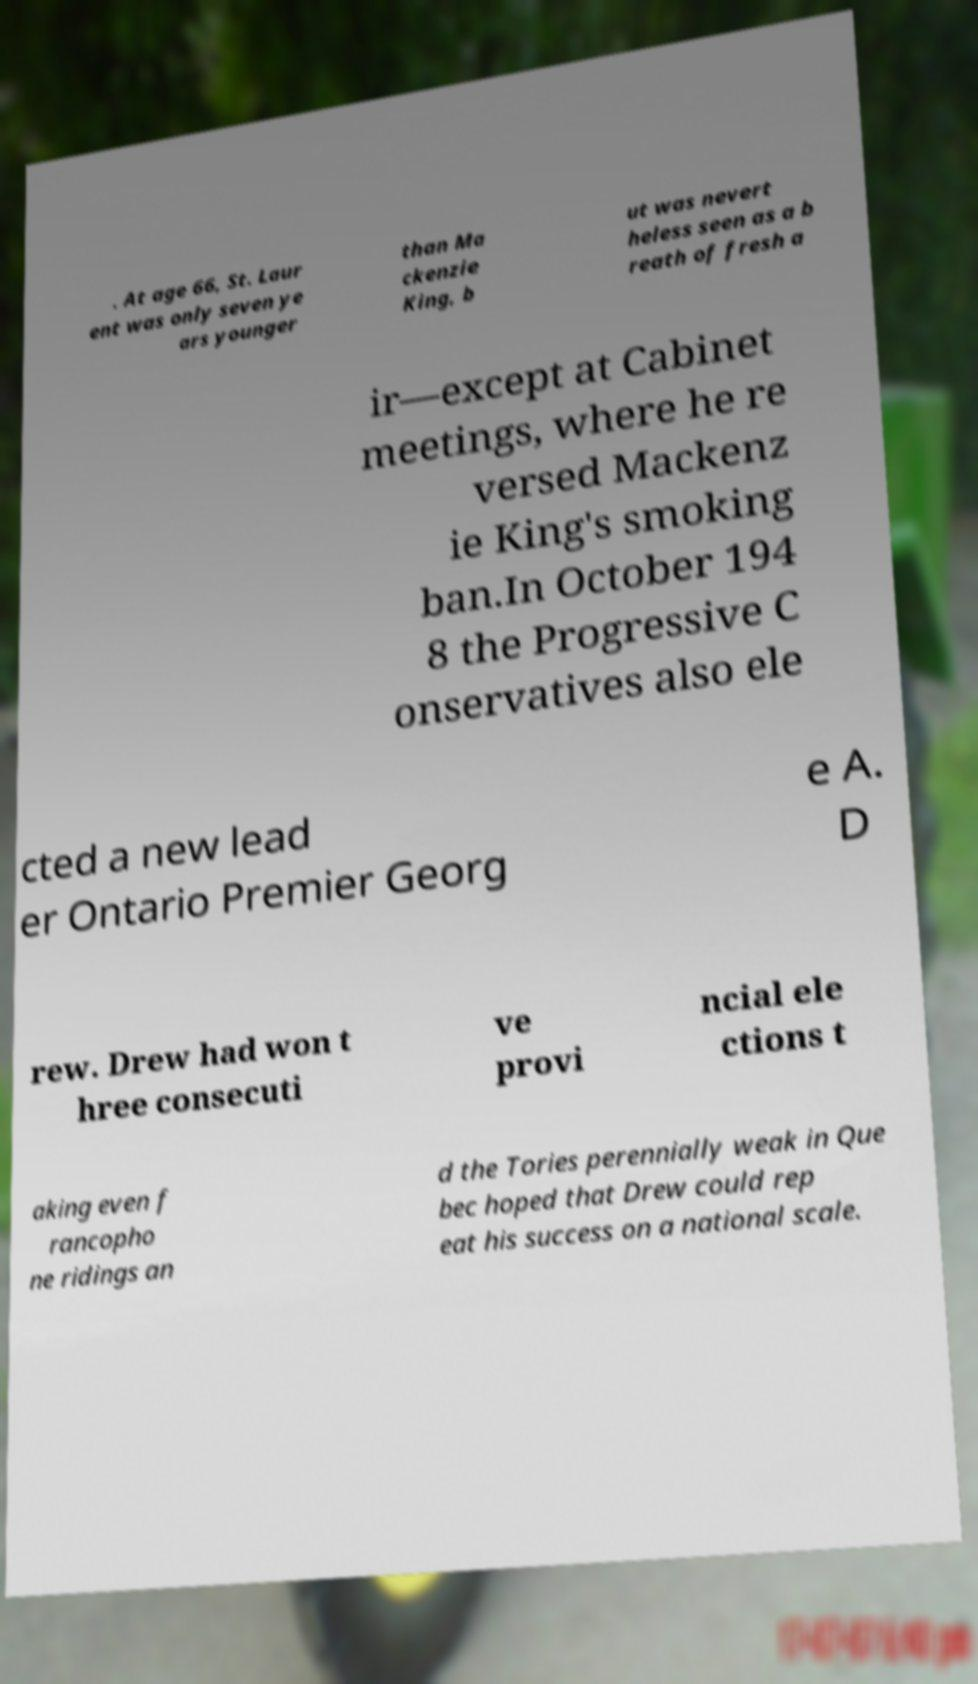Can you accurately transcribe the text from the provided image for me? . At age 66, St. Laur ent was only seven ye ars younger than Ma ckenzie King, b ut was nevert heless seen as a b reath of fresh a ir—except at Cabinet meetings, where he re versed Mackenz ie King's smoking ban.In October 194 8 the Progressive C onservatives also ele cted a new lead er Ontario Premier Georg e A. D rew. Drew had won t hree consecuti ve provi ncial ele ctions t aking even f rancopho ne ridings an d the Tories perennially weak in Que bec hoped that Drew could rep eat his success on a national scale. 